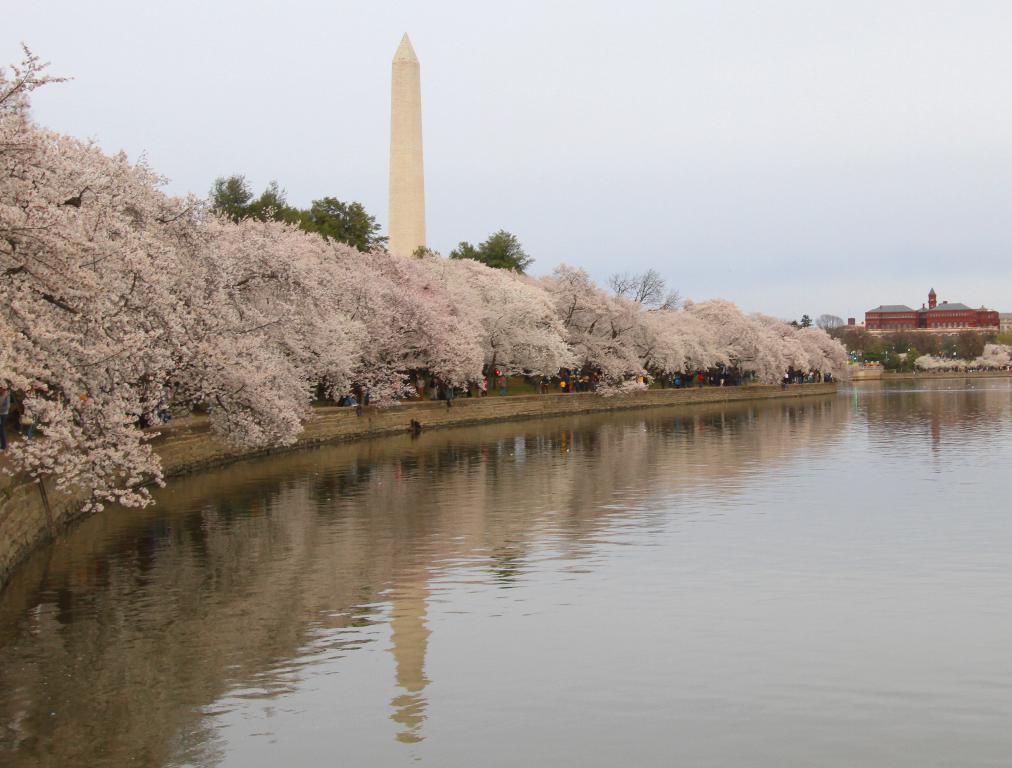Can you describe this image briefly? In this picture there is water. To the left there are trees on the ground. In the background there are buildings. At the top there is the sky. In the center there is a tower. 